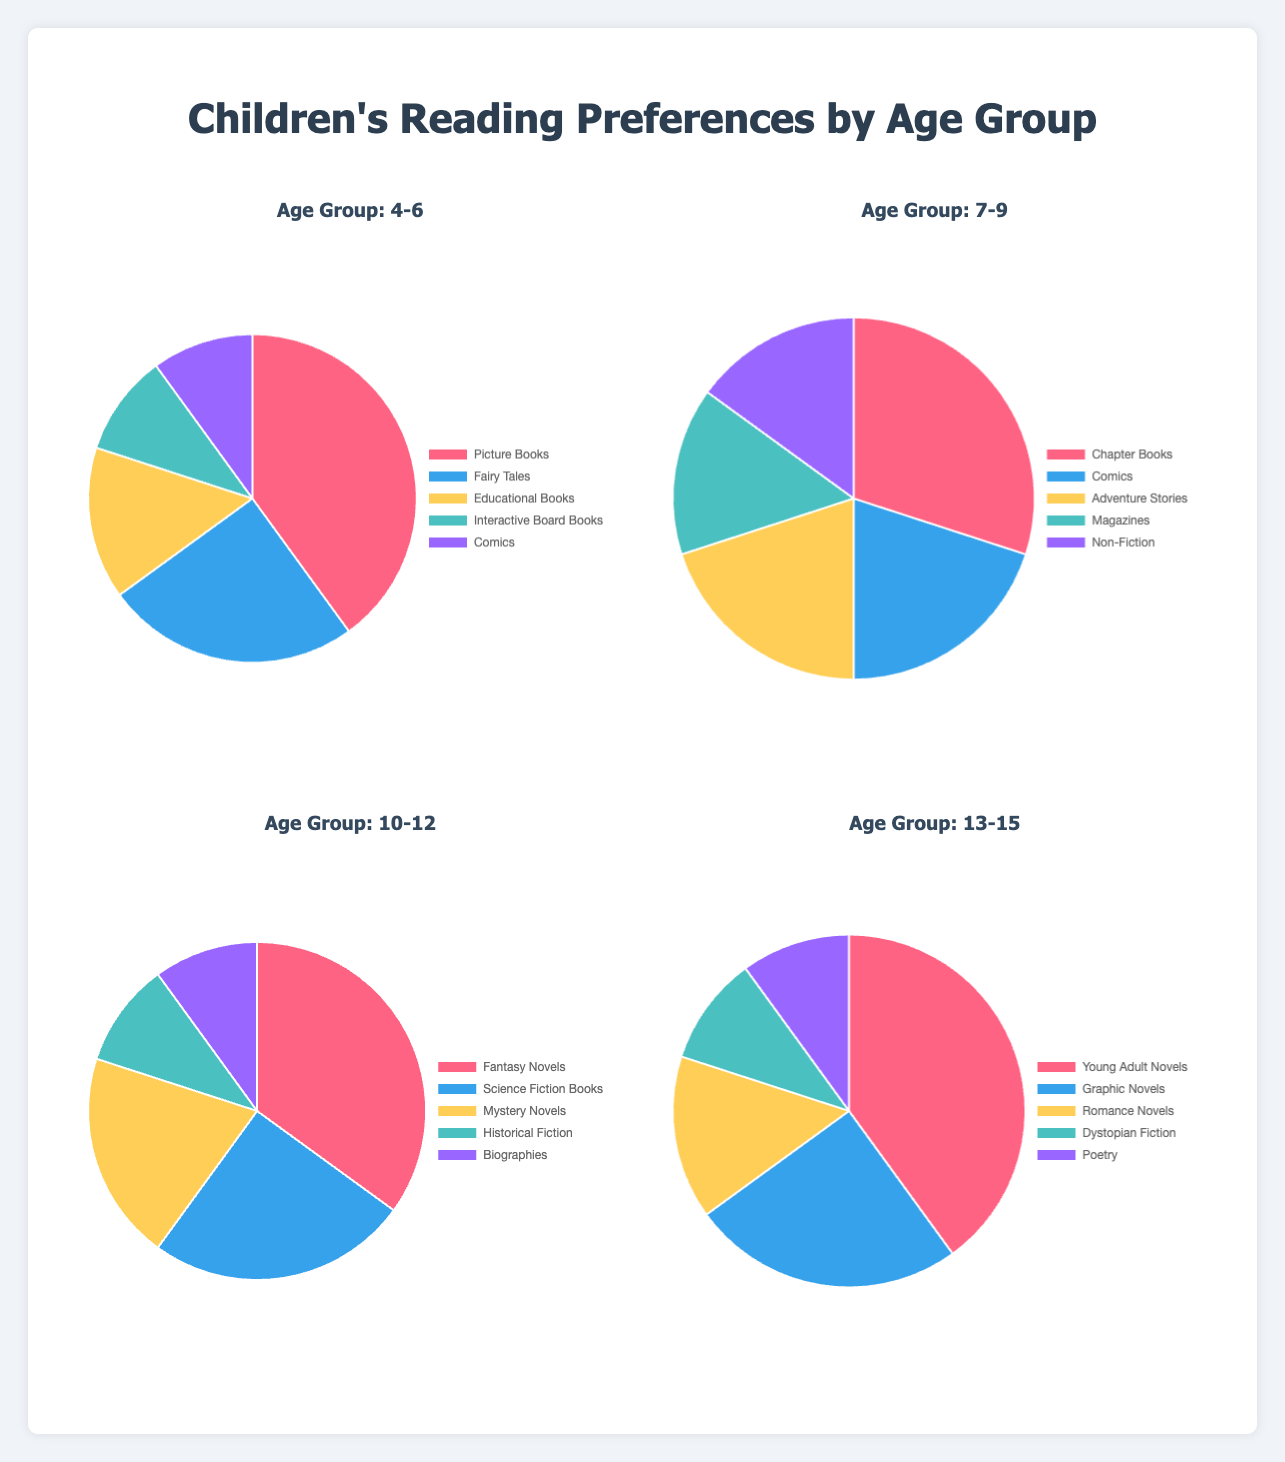Which reading material is most preferred by children aged 4-6? The chart for the age group 4-6 shows that "Picture Books" have the highest percentage.
Answer: Picture Books What percentage of children aged 7-9 prefer comics? In the chart for age group 7-9, "Comics" are represented by one of the slices labeled with its percentage. This percentage is 20%.
Answer: 20% How does the percentage of children who prefer "Adventure Stories" compare between age groups 7-9 and 10-12? The chart for age group 7-9 shows that 20% prefer "Adventure Stories." For age group 10-12, "Adventure Stories" is not listed, implying this preference is 0%. Comparing these, 20% is greater than 0%.
Answer: 20% is greater Add up the percentages of "Picture Books", "Fairy Tales", and "Educational Books" for children aged 4-6. From the chart for age group 4-6, the percentages are 40% (Picture Books), 25% (Fairy Tales), and 15% (Educational Books). Adding these together gives 40 + 25 + 15 = 80%.
Answer: 80% Which type of reading material is preferred equally by children in the age groups 4-6 and 13-15? The charts show the types of reading materials and their respective percentages. Both age groups 4-6 and 13-15 have "Comics" and "Poetry" listed at 10%.
Answer: Comics and Poetry Compare the preference for "Fantasty Novels" and "Science Fiction Books" among the 10-12 age group and determine the difference in their percentages. The chart for age group 10-12 shows "Fantasy Novels" at 35% and "Science Fiction Books" at 25%. The difference is 35 - 25 = 10%.
Answer: 10% Which age group has the lowest percentage of children preferring non-fictional reading materials? "Non-Fiction" reading materials appear only in the age group 7-9 with a percentage of 15%, whereas other age groups do not list "Non-Fiction," implying 0%. Thus, groups 4-6, 10-12, and 13-15 all have lower percentages than 7-9.
Answer: 4-6, 10-12, and 13-15 What reading material has the highest preference among children aged 10-12? Looking at the chart for age group 10-12, "Fantasy Novels" have the highest percentage at 35%.
Answer: Fantasy Novels What is the combined preference percentage of "Young Adult Novels" and "Romance Novels" for the age group 13-15? In the chart for age group 13-15, "Young Adult Novels" are preferred by 40% and "Romance Novels" by 15%. Adding these gives 40 + 15 = 55%.
Answer: 55% Compare the preference percentages for "Comics" in the age groups 4-6 and 7-9. From the charts, "Comics" are 10% for age group 4-6 and 20% for age group 7-9. 20% is greater than 10%.
Answer: 20% is greater 